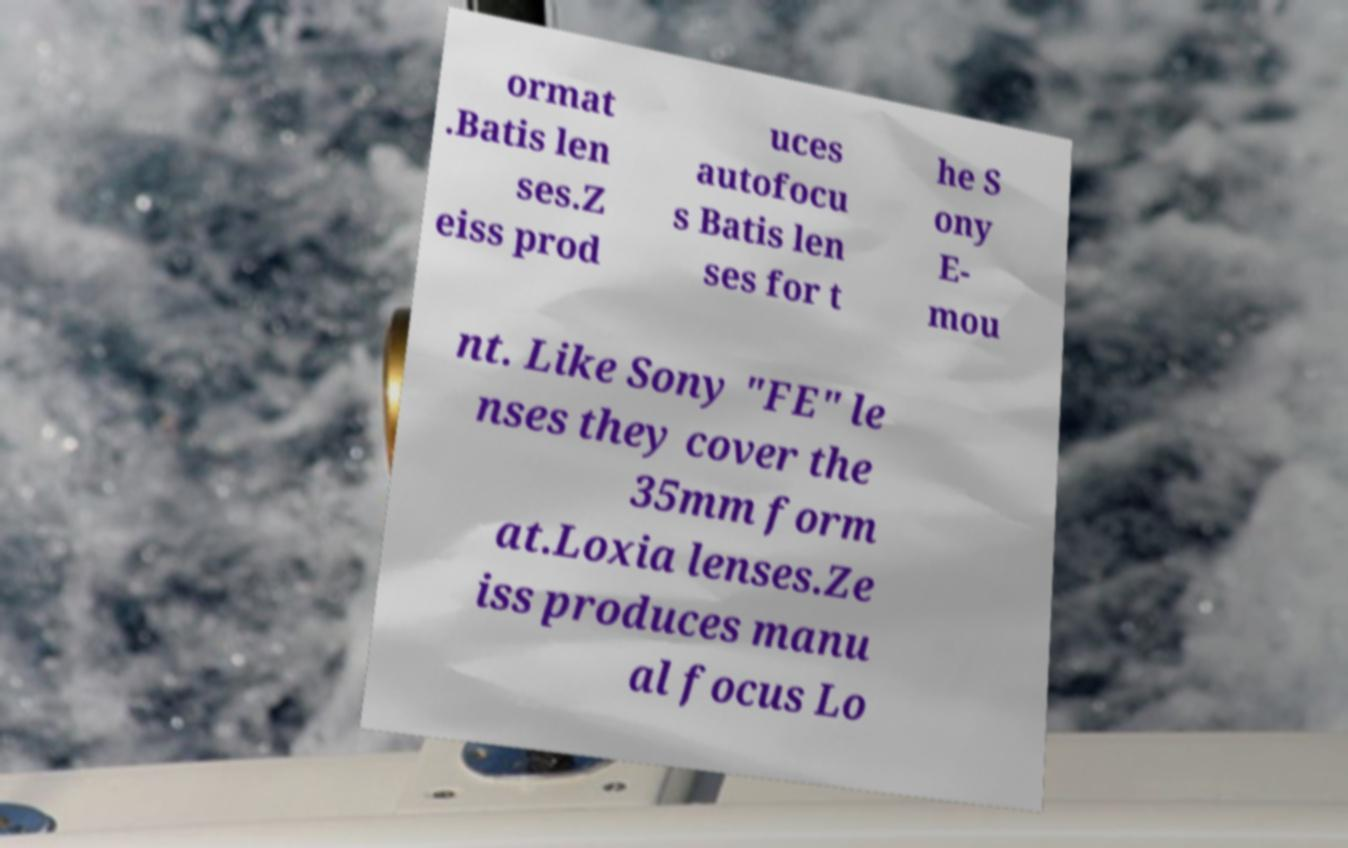Please identify and transcribe the text found in this image. ormat .Batis len ses.Z eiss prod uces autofocu s Batis len ses for t he S ony E- mou nt. Like Sony "FE" le nses they cover the 35mm form at.Loxia lenses.Ze iss produces manu al focus Lo 